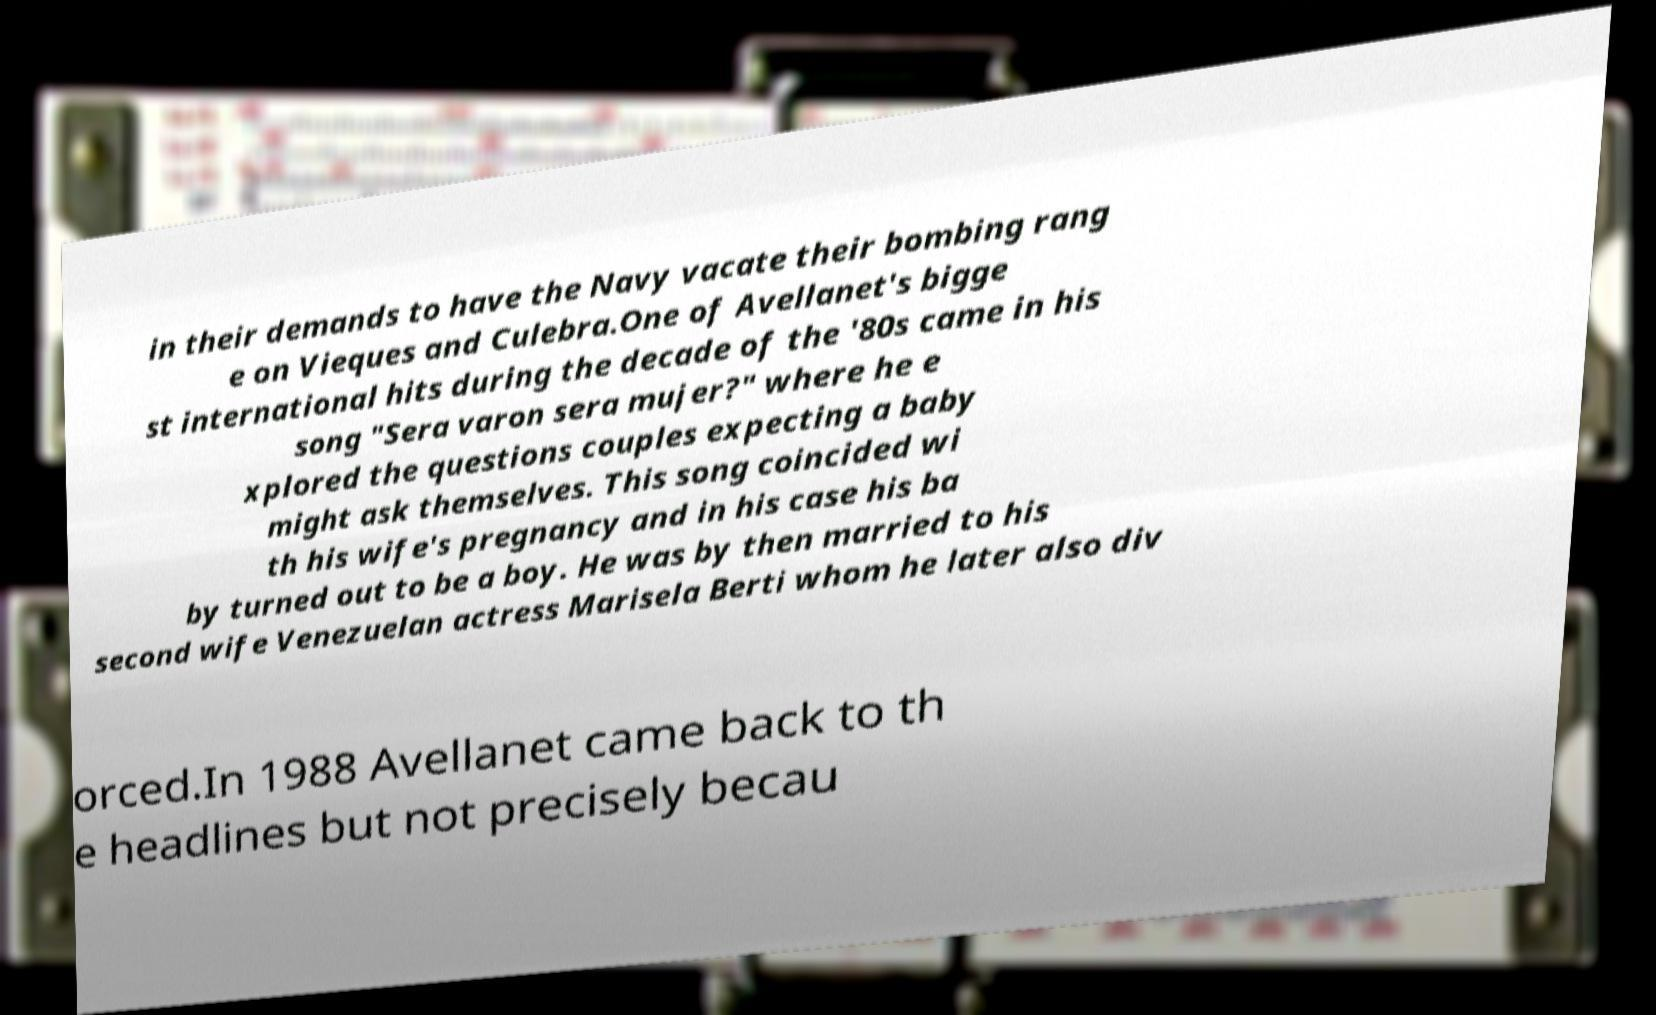There's text embedded in this image that I need extracted. Can you transcribe it verbatim? in their demands to have the Navy vacate their bombing rang e on Vieques and Culebra.One of Avellanet's bigge st international hits during the decade of the '80s came in his song "Sera varon sera mujer?" where he e xplored the questions couples expecting a baby might ask themselves. This song coincided wi th his wife's pregnancy and in his case his ba by turned out to be a boy. He was by then married to his second wife Venezuelan actress Marisela Berti whom he later also div orced.In 1988 Avellanet came back to th e headlines but not precisely becau 